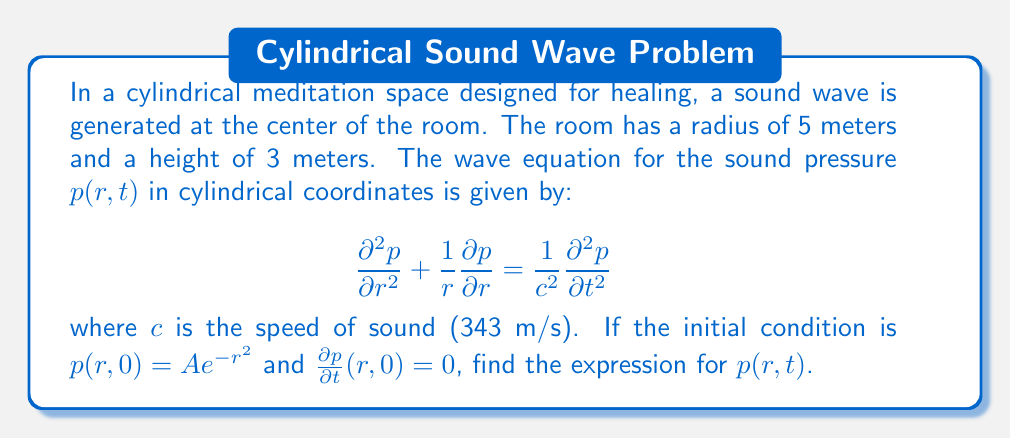What is the answer to this math problem? To solve this wave equation, we'll follow these steps:

1) First, we assume a solution of the form $p(r,t) = R(r)T(t)$.

2) Substituting this into the wave equation:

   $$\frac{T''}{c^2T} = \frac{R'' + \frac{1}{r}R'}{R} = -k^2$$

   where $k$ is a separation constant.

3) This gives us two ordinary differential equations:
   
   $$T'' + c^2k^2T = 0$$
   $$r^2R'' + rR' + k^2r^2R = 0$$

4) The solution for $T(t)$ is:
   
   $$T(t) = A\cos(ckt) + B\sin(ckt)$$

5) The equation for $R(r)$ is the Bessel equation of order zero. Its solution is:
   
   $$R(r) = CJ_0(kr) + DY_0(kr)$$

   where $J_0$ and $Y_0$ are Bessel functions of the first and second kind.

6) Since $Y_0$ is singular at $r=0$, and we need our solution to be finite at the center, $D=0$.

7) The general solution is thus:

   $$p(r,t) = \int_0^\infty [E(k)\cos(ckt) + F(k)\sin(ckt)]J_0(kr)dk$$

8) Using the initial conditions:

   $p(r,0) = Ae^{-r^2} = \int_0^\infty E(k)J_0(kr)dk$
   
   $\frac{\partial p}{\partial t}(r,0) = 0 = \int_0^\infty ckF(k)J_0(kr)dk$

9) From the second condition, $F(k) = 0$ for all $k$.

10) The first condition is a Hankel transform. Its inverse gives:

    $$E(k) = A\int_0^\infty re^{-r^2}J_0(kr)dr = \frac{A}{2}e^{-k^2/4}$$

11) Therefore, the final solution is:

    $$p(r,t) = \frac{A}{2}\int_0^\infty e^{-k^2/4}\cos(ckt)J_0(kr)dk$$
Answer: $p(r,t) = \frac{A}{2}\int_0^\infty e^{-k^2/4}\cos(ckt)J_0(kr)dk$ 